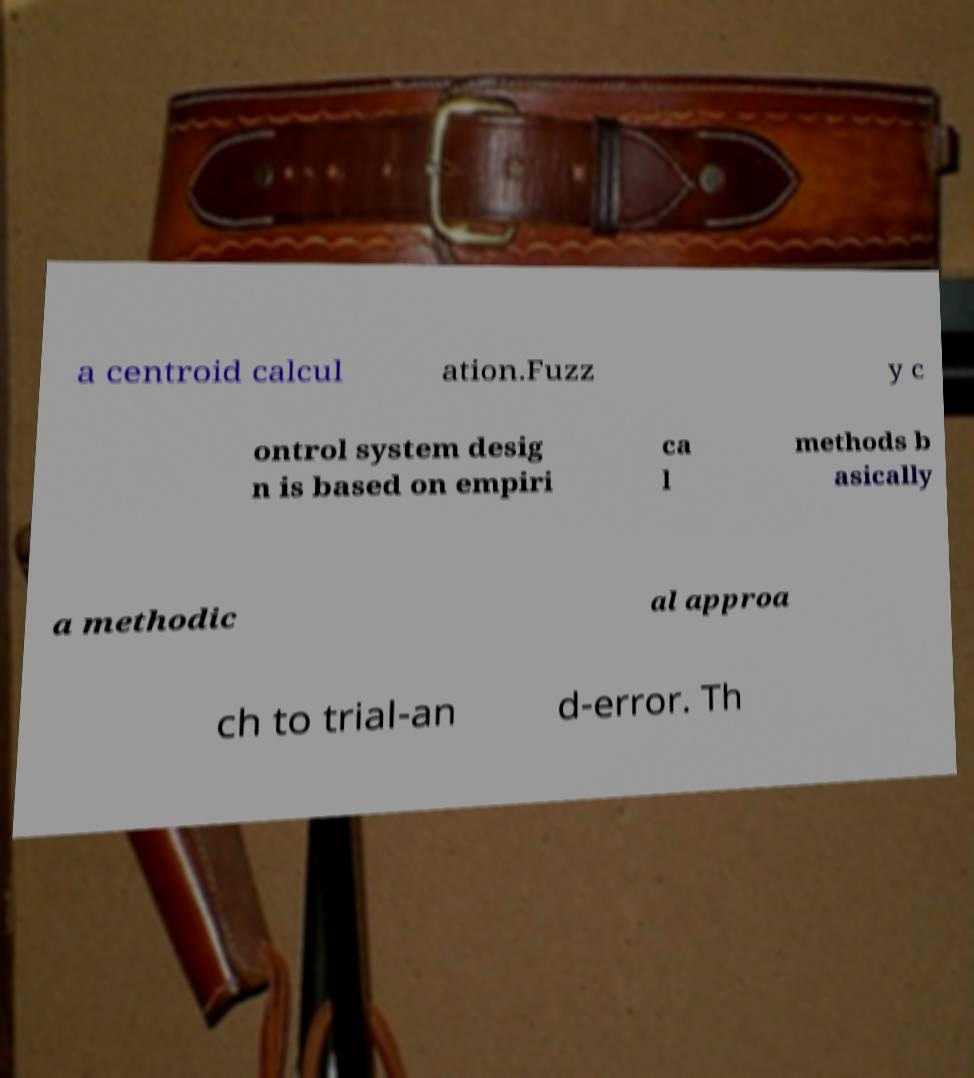What messages or text are displayed in this image? I need them in a readable, typed format. a centroid calcul ation.Fuzz y c ontrol system desig n is based on empiri ca l methods b asically a methodic al approa ch to trial-an d-error. Th 